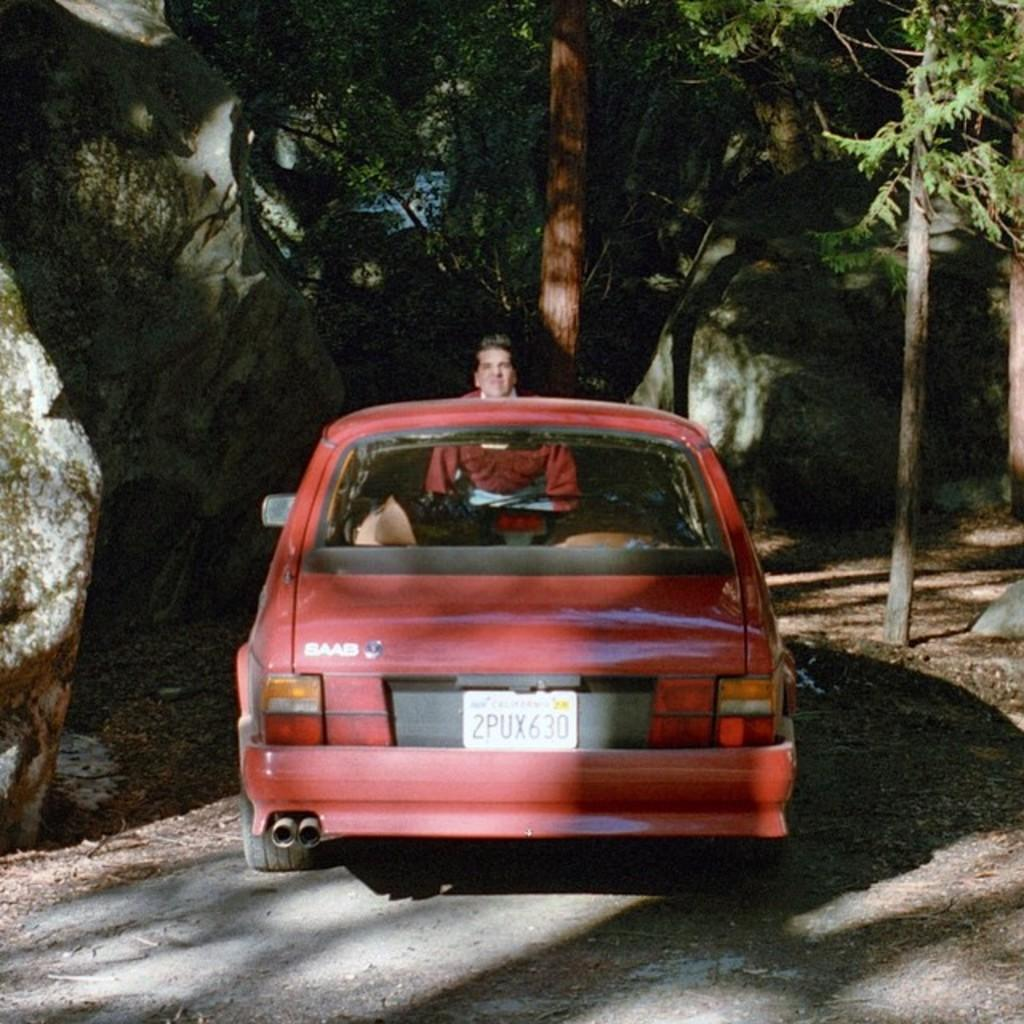What is the main subject on the road in the image? There is a vehicle on the road in the image. Can you describe the person in the image? There is a person in the image. What type of natural vegetation is visible in the image? There are trees in the image. What type of geological formation is present in the image? There are rocks in the image. What country is the person in the image from? The provided facts do not mention the person's country of origin, so it cannot be determined from the image. How does the vehicle burn fuel in the image? The provided facts do not mention the vehicle's fuel source or how it burns fuel, so it cannot be determined from the image. Can you tell me how the vehicle sails on the road in the image? The provided facts do not mention the vehicle sailing on the road, as vehicles typically do not sail. 